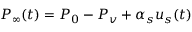Convert formula to latex. <formula><loc_0><loc_0><loc_500><loc_500>P _ { \infty } ( t ) = P _ { 0 } - P _ { v } + \alpha _ { s } u _ { s } ( t )</formula> 